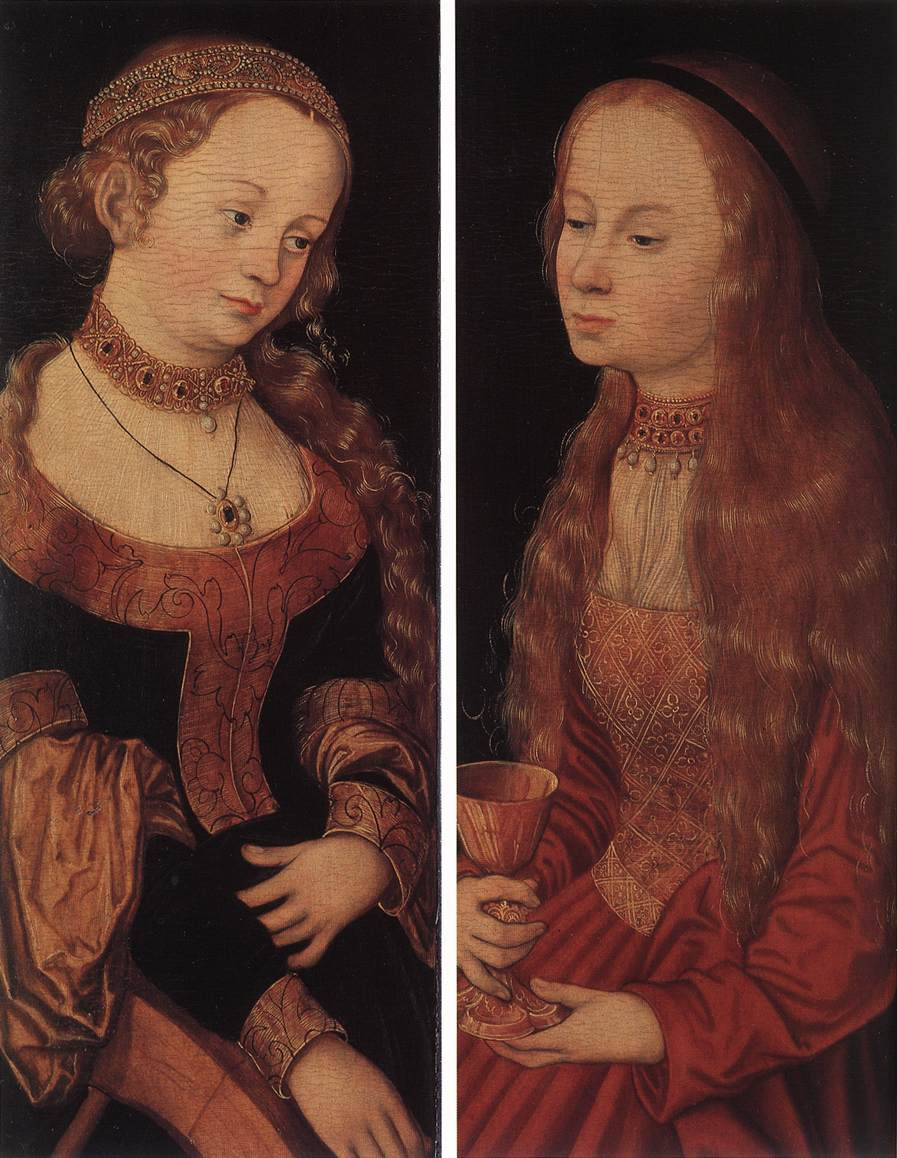If this painting were a scene in a movie, what would be the plot? In a movie inspired by this painting, the story could unfold around two noble sisters living in a Renaissance-era kingdom. Each sister embodies distinct virtues and talents – wisdom and scholarly pursuits for the blonde sister, creativity and a spiritual journey for the red-haired sister.

The plot revolves around their quest to unite these virtues to save their homeland from a looming shadow. The elder sister discovers an ancient text that reveals a prophecy, requiring the blending of wisdom and divine grace. The younger sister's visions guide them on a perilous journey to uncover hidden truths, gather allies, and confront the forces threatening their world. Their bond and complementary strengths ultimately become the linchpin in restoring balance and harmony to their kingdom. 